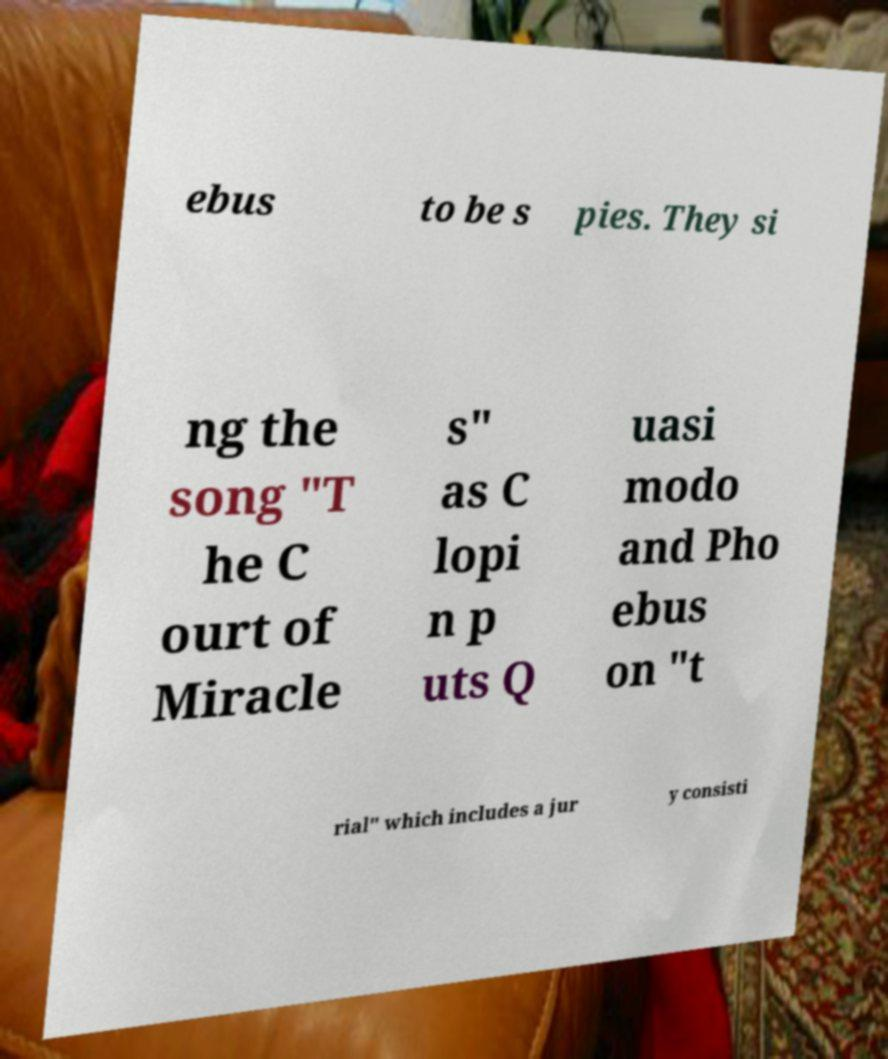I need the written content from this picture converted into text. Can you do that? ebus to be s pies. They si ng the song "T he C ourt of Miracle s" as C lopi n p uts Q uasi modo and Pho ebus on "t rial" which includes a jur y consisti 